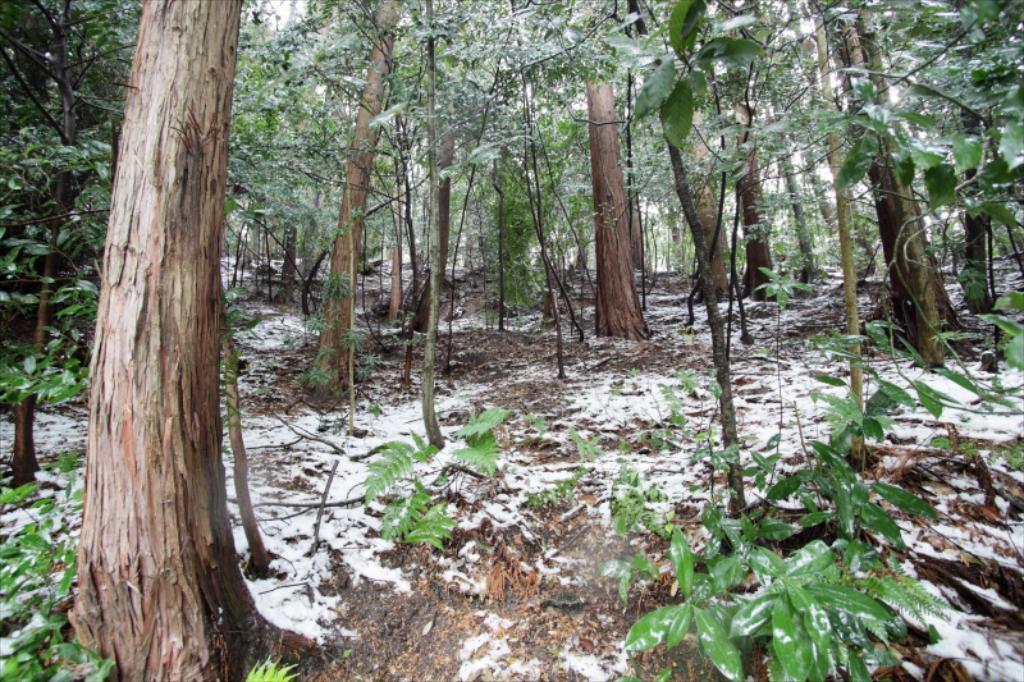In one or two sentences, can you explain what this image depicts? In this image there are trees. At the bottom there are plants and snow. 